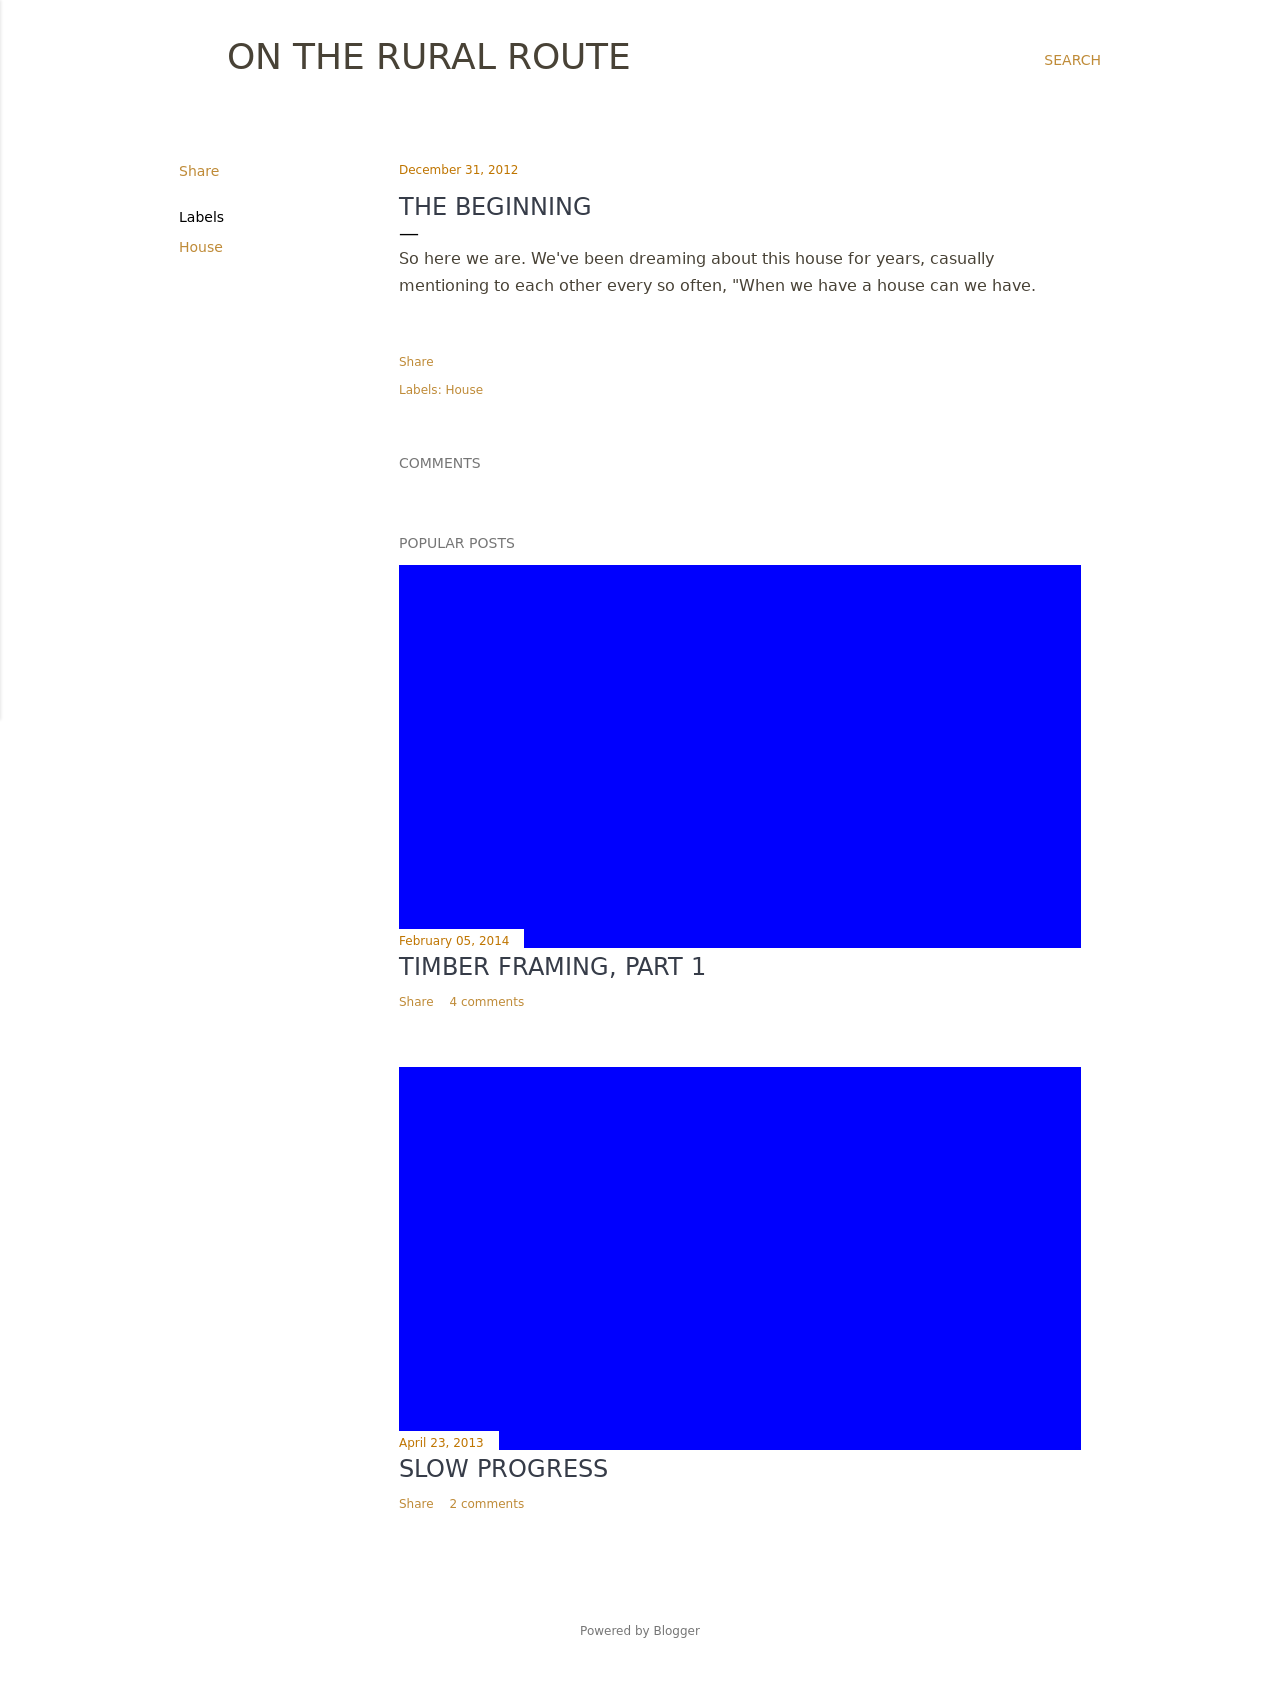Can you suggest ways to make the text more engaging for readers interested in rural living? To engage readers with an interest in rural living, incorporate captivating headlines and introductory paragraphs that evoke the peacefulness and beauty of rural life. Use rich, descriptive language and include personal stories or anecdotes. Consider adding a blog or news section to the website to share updates, events or personal reflections that resonate with the rural lifestyle.  What would be an effective method to visually emphasize these stories? Visually emphasize these stories by using high-quality photos of rural scenery that relate to the content. Place these images near the top of your posts to draw readers in. Additionally, using a clean, minimalist design with earthy colors can also highlight the rural theme of the website. 